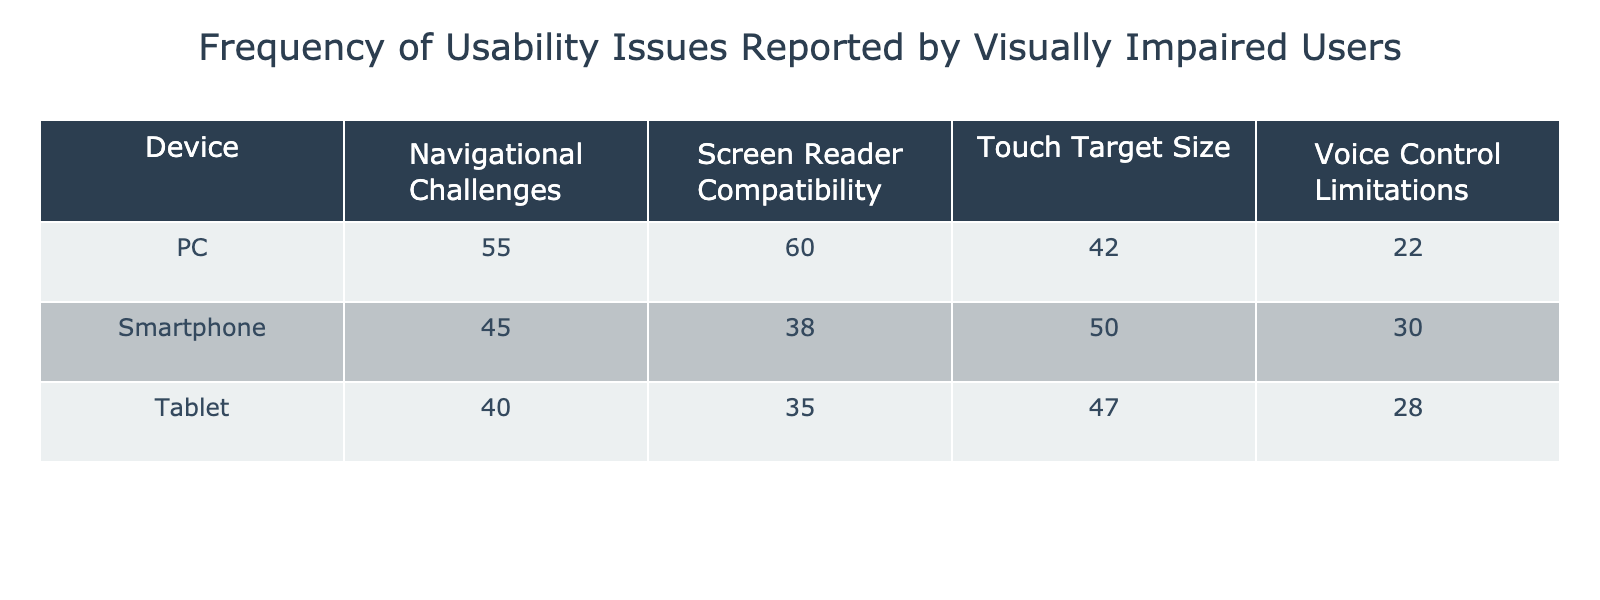What is the frequency of Navigational Challenges reported by visually impaired users on smartphones? From the table, look under the smartphone row in the Navigational Challenges column. It shows a frequency of 45 for this usability issue.
Answer: 45 Which device had the highest frequency of Screen Reader Compatibility issues? By examining the Screen Reader Compatibility column, the highest value is in the PC row, which is 60. Therefore, the PC device reports the most issues in this category.
Answer: PC What is the average frequency of Touch Target Size issues across all devices? Adding the frequencies for Touch Target Size across devices: Smartphone (50), Tablet (47), and PC (42). The total is 50 + 47 + 42 = 139. There are three devices, so the average is 139/3 = 46.33.
Answer: 46.33 Are Voice Control Limitations reported more frequently on smartphones than tablets? The frequency for Voice Control Limitations on smartphones is 30, and on tablets, it is 28. Since 30 is greater than 28, the statement is true.
Answer: Yes Which device has the lowest overall usability issues reported? To determine the device with the lowest overall issues, sum the frequencies for each device: Smartphone (45 + 38 + 50 + 30 = 163), Tablet (40 + 35 + 47 + 28 = 150), and PC (55 + 60 + 42 + 22 = 179). Tablet has the least total frequency, which is 150.
Answer: Tablet Is the total frequency of usability issues for PCs greater than that of smartphones? Calculate the total frequency for each: Smartphone totals 163, and PC totals 179. Since 179 is greater than 163, the statement is true.
Answer: Yes What is the sum of all frequencies related to Touch Target Size issues? The sum of Touch Target Size issues is 50 (Smartphone) + 47 (Tablet) + 42 (PC) = 139. This gives the total frequency for this usability issue across devices.
Answer: 139 Which usability issue is reported the least frequently on PCs? Looking under the PC column, the usability issue with the lowest frequency is Voice Control Limitations, which is 22.
Answer: Voice Control Limitations 